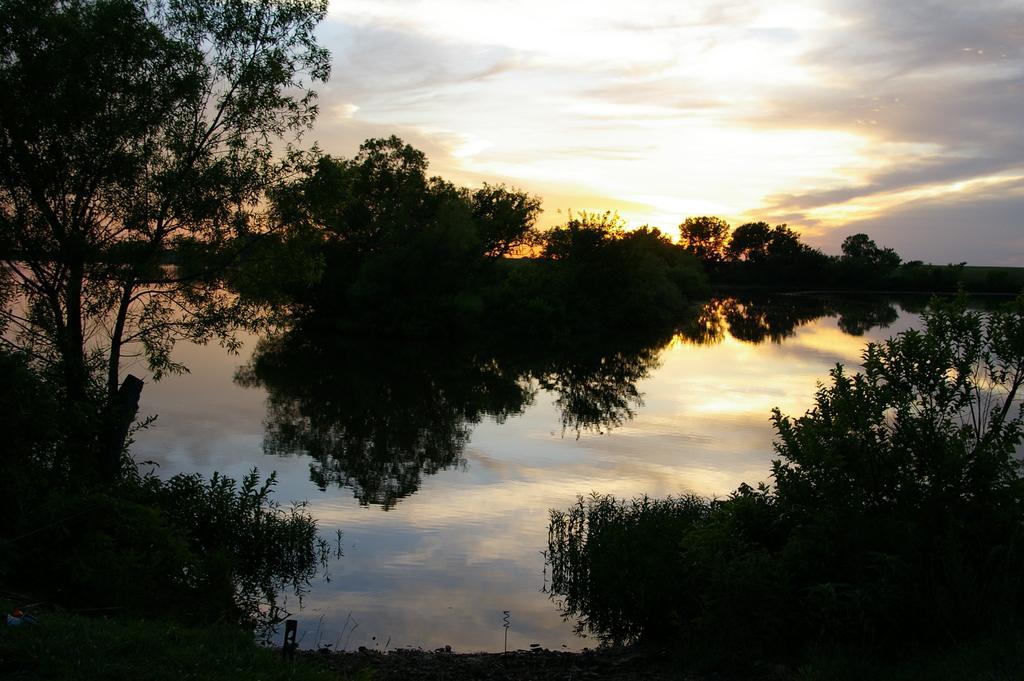How would you summarize this image in a sentence or two? In this image at the bottom there is a river and some plants, and in the background there are some trees. On the top of the image there is sky. 